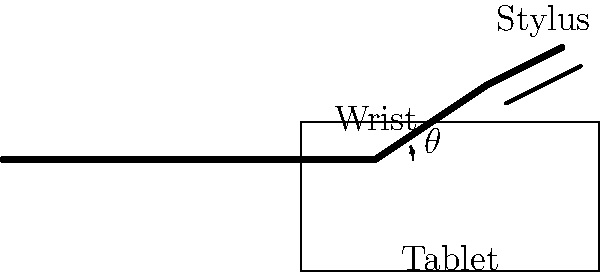In the diagram, the wrist angle $\theta$ is shown when using a digital tablet for art. What is the recommended range for this angle to minimize the risk of repetitive strain injury (RSI) while maintaining comfort and control? To determine the recommended wrist angle range for digital tablet use, we need to consider several factors:

1. Neutral wrist position: The ideal position is when the wrist is in a neutral, straight alignment with the forearm. This minimizes stress on the tendons and nerves passing through the carpal tunnel.

2. Range of motion: The wrist has a natural range of motion, but extreme angles can cause strain over time.

3. Ergonomic guidelines: Occupational health experts generally recommend maintaining the wrist within 15 degrees of the neutral position in any direction.

4. Task requirements: Digital art often requires fine motor control, which may be compromised if the wrist is completely straight.

5. Individual variations: Some artists may have slightly different optimal angles based on their anatomy and work style.

Considering these factors, the recommended range for the wrist angle $\theta$ when using a digital tablet for art is typically between 0 and 20 degrees of extension (upward bend). This range allows for:

- Minimal deviation from the neutral position
- Sufficient control for precise stylus movements
- Reduced risk of compression on the median nerve
- Comfortable positioning for extended periods of work

It's important to note that this range is a general guideline. Artists should also:
- Take frequent breaks
- Vary their hand and wrist positions throughout the work session
- Ensure proper overall posture and equipment setup
Answer: 0-20 degrees of extension 